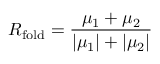<formula> <loc_0><loc_0><loc_500><loc_500>R _ { f o l d } = \frac { \mu _ { 1 } + \mu _ { 2 } } { | \mu _ { 1 } | + | \mu _ { 2 } | }</formula> 